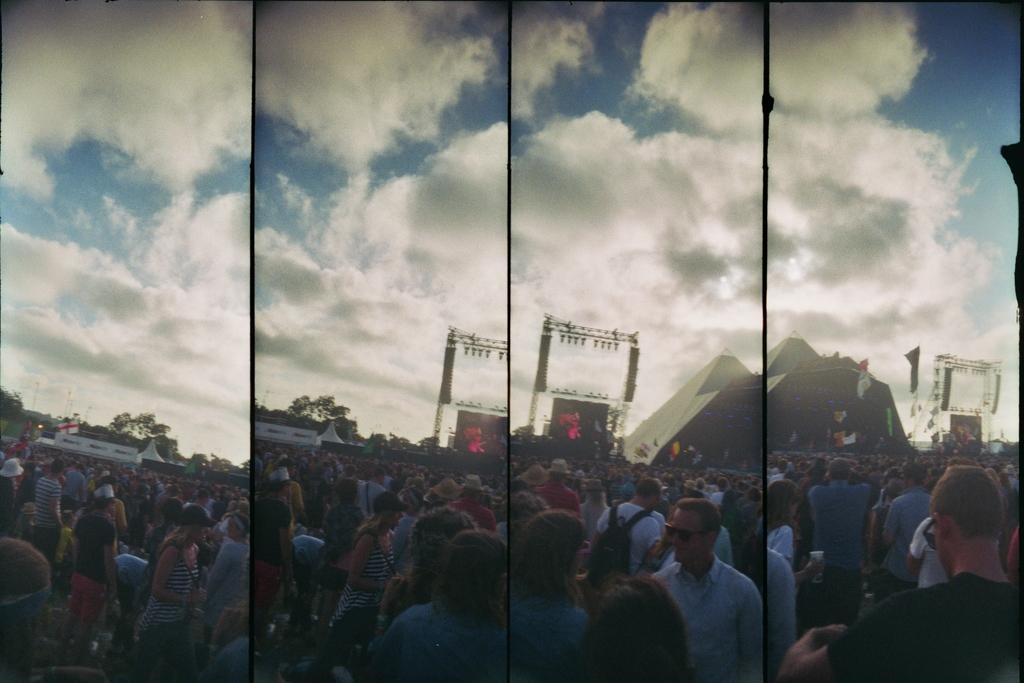What type of pictures are present in the image? There are collage pictures of persons in the image. What can be seen in the background of the image? The sky is visible in the image. What type of feather can be seen floating in the sky in the image? There is no feather present in the image; only collage pictures of persons and the sky are visible. 